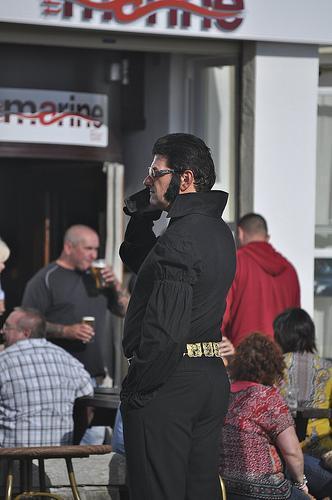How many beers is the bald man holding?
Give a very brief answer. 2. How many elephants are pictured?
Give a very brief answer. 0. How many dinosaurs are in the picture?
Give a very brief answer. 0. How many people are wearing a red hoodie?
Give a very brief answer. 1. How many glasses of beer is the man in the background holding?
Give a very brief answer. 2. How many people are wearing a plaid shirt?
Give a very brief answer. 1. How many birds are pictured?
Give a very brief answer. 0. 